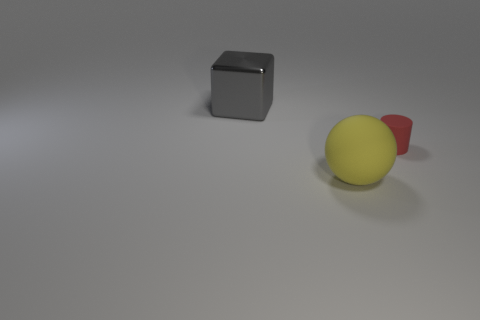There is a object that is on the left side of the matte object that is in front of the red rubber cylinder that is to the right of the yellow matte sphere; what is it made of?
Your answer should be compact. Metal. There is a yellow thing that is the same material as the tiny red cylinder; what is its shape?
Provide a short and direct response. Sphere. There is a object that is behind the red rubber object; is there a red matte cylinder that is behind it?
Keep it short and to the point. No. The yellow matte thing has what size?
Ensure brevity in your answer.  Large. How many things are either large yellow matte spheres or gray metal blocks?
Offer a very short reply. 2. Does the object that is right of the big rubber ball have the same material as the big thing behind the yellow object?
Give a very brief answer. No. There is a sphere that is made of the same material as the red cylinder; what color is it?
Your answer should be very brief. Yellow. How many gray blocks are the same size as the sphere?
Offer a very short reply. 1. How many other things are there of the same color as the small thing?
Ensure brevity in your answer.  0. Is there any other thing that has the same size as the red thing?
Ensure brevity in your answer.  No. 